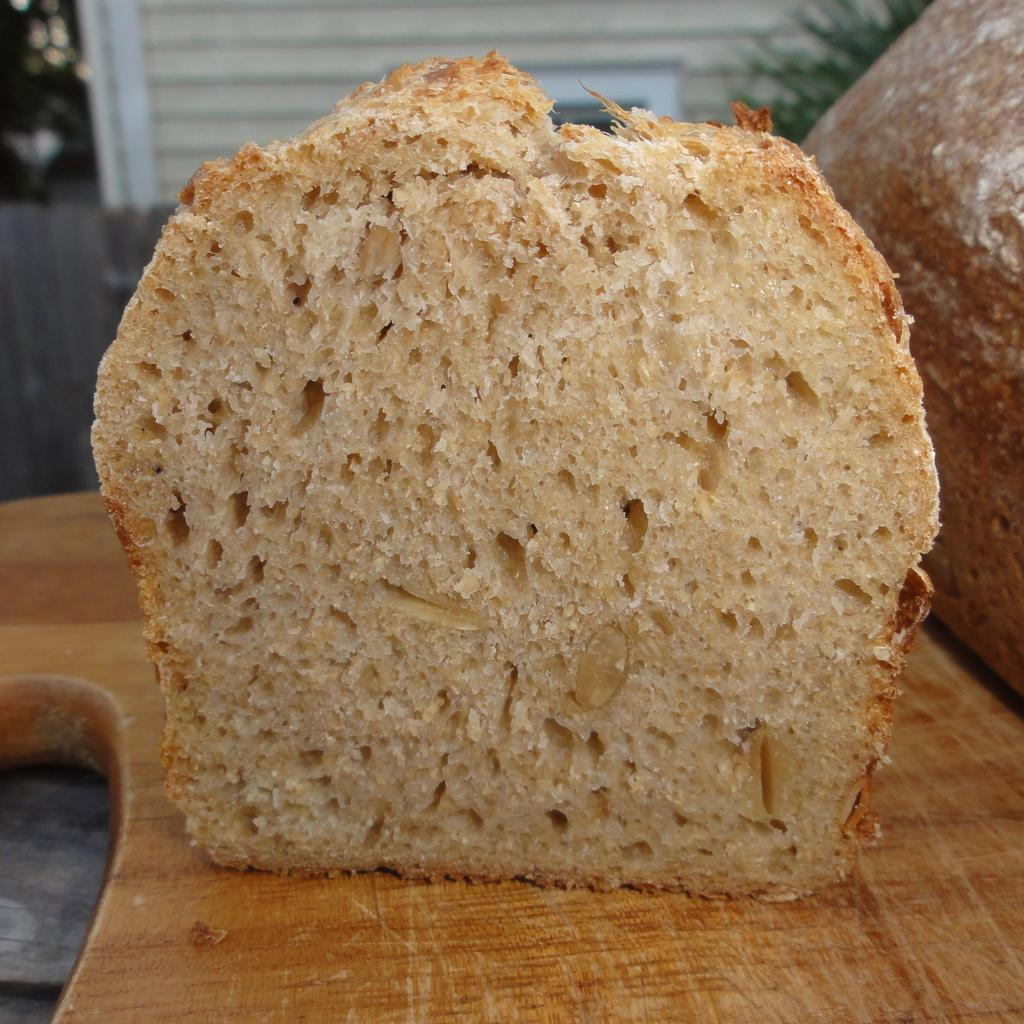What type of food can be seen in the image? There is sliced bread in the image. On what surface is the sliced bread placed? The sliced bread is on a wooden surface. What can be seen in the background of the image? The provided facts do not specify what is visible in the background of the image. How many cherries are hanging from the branch in the image? There are no cherries or branches present in the image. 